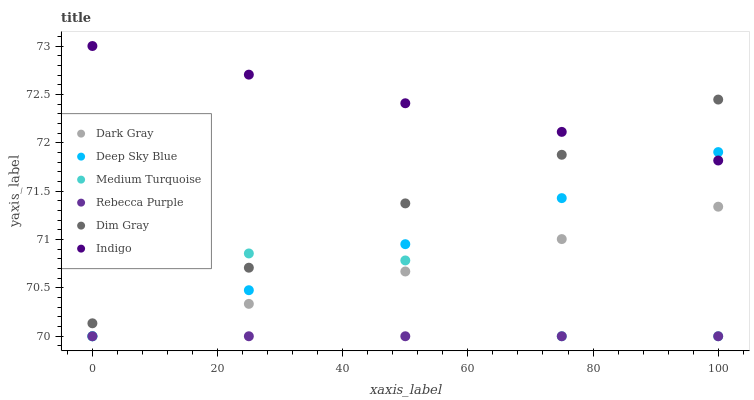Does Rebecca Purple have the minimum area under the curve?
Answer yes or no. Yes. Does Indigo have the maximum area under the curve?
Answer yes or no. Yes. Does Deep Sky Blue have the minimum area under the curve?
Answer yes or no. No. Does Deep Sky Blue have the maximum area under the curve?
Answer yes or no. No. Is Dark Gray the smoothest?
Answer yes or no. Yes. Is Medium Turquoise the roughest?
Answer yes or no. Yes. Is Indigo the smoothest?
Answer yes or no. No. Is Indigo the roughest?
Answer yes or no. No. Does Deep Sky Blue have the lowest value?
Answer yes or no. Yes. Does Indigo have the lowest value?
Answer yes or no. No. Does Indigo have the highest value?
Answer yes or no. Yes. Does Deep Sky Blue have the highest value?
Answer yes or no. No. Is Rebecca Purple less than Dim Gray?
Answer yes or no. Yes. Is Indigo greater than Rebecca Purple?
Answer yes or no. Yes. Does Dark Gray intersect Medium Turquoise?
Answer yes or no. Yes. Is Dark Gray less than Medium Turquoise?
Answer yes or no. No. Is Dark Gray greater than Medium Turquoise?
Answer yes or no. No. Does Rebecca Purple intersect Dim Gray?
Answer yes or no. No. 